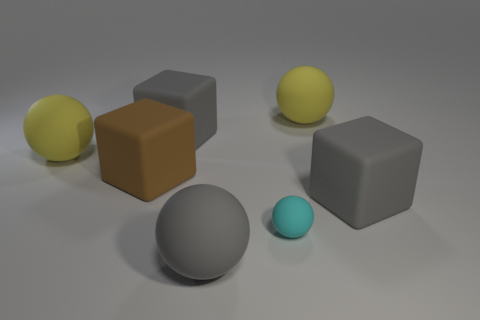Add 2 large yellow things. How many objects exist? 9 Subtract all balls. How many objects are left? 3 Add 4 big rubber cubes. How many big rubber cubes exist? 7 Subtract 0 yellow cylinders. How many objects are left? 7 Subtract all big cubes. Subtract all cyan objects. How many objects are left? 3 Add 3 gray rubber objects. How many gray rubber objects are left? 6 